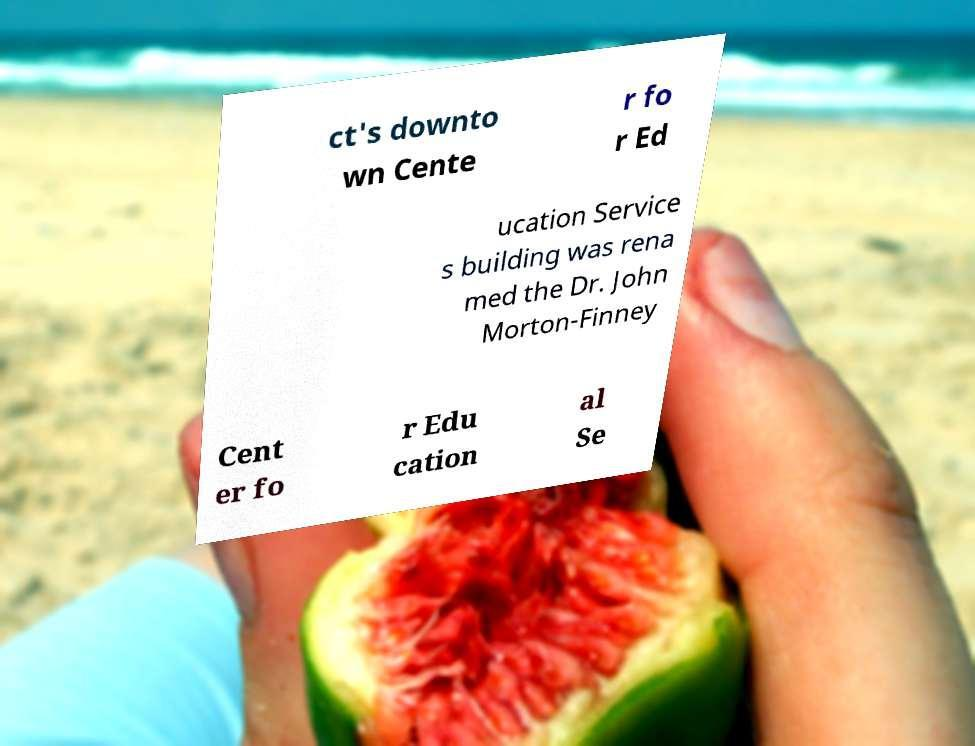Please identify and transcribe the text found in this image. ct's downto wn Cente r fo r Ed ucation Service s building was rena med the Dr. John Morton-Finney Cent er fo r Edu cation al Se 